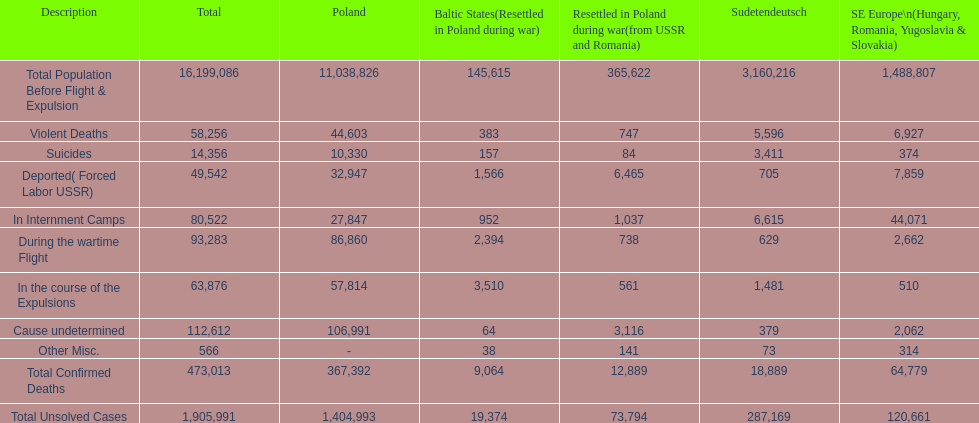What is the dissimilarity between suicides in poland and sudetendeutsch? 6919. 